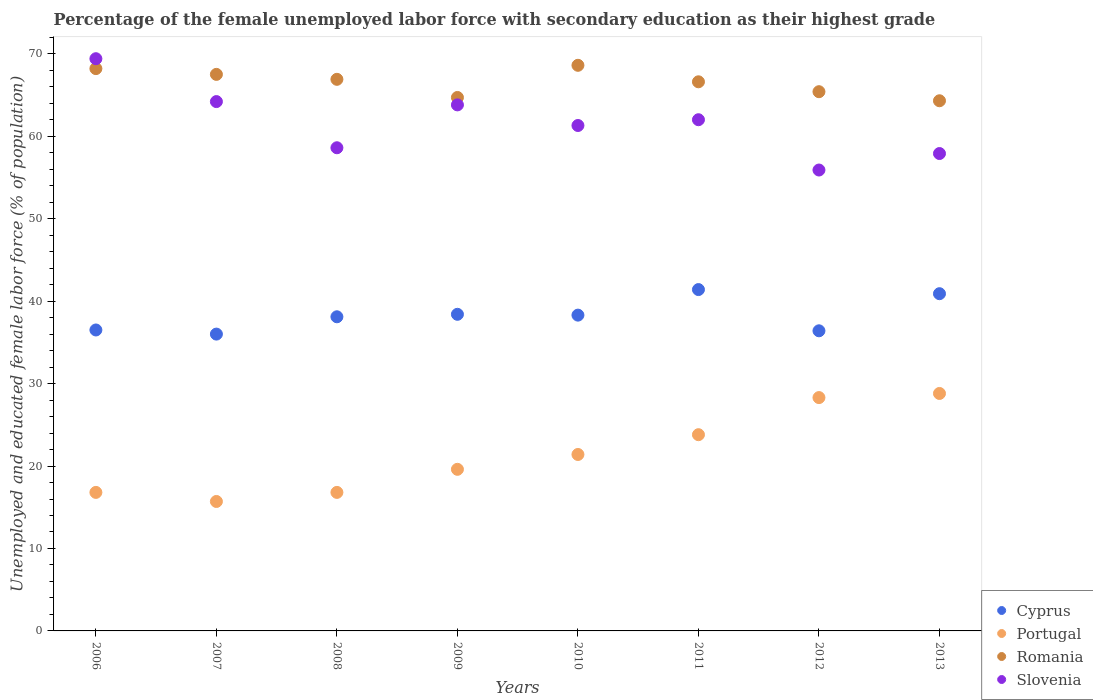How many different coloured dotlines are there?
Keep it short and to the point. 4. What is the percentage of the unemployed female labor force with secondary education in Cyprus in 2006?
Ensure brevity in your answer.  36.5. Across all years, what is the maximum percentage of the unemployed female labor force with secondary education in Portugal?
Make the answer very short. 28.8. In which year was the percentage of the unemployed female labor force with secondary education in Romania minimum?
Offer a very short reply. 2013. What is the total percentage of the unemployed female labor force with secondary education in Romania in the graph?
Provide a short and direct response. 532.2. What is the difference between the percentage of the unemployed female labor force with secondary education in Romania in 2009 and that in 2013?
Give a very brief answer. 0.4. What is the difference between the percentage of the unemployed female labor force with secondary education in Cyprus in 2006 and the percentage of the unemployed female labor force with secondary education in Slovenia in 2009?
Ensure brevity in your answer.  -27.3. What is the average percentage of the unemployed female labor force with secondary education in Romania per year?
Provide a succinct answer. 66.52. In the year 2008, what is the difference between the percentage of the unemployed female labor force with secondary education in Slovenia and percentage of the unemployed female labor force with secondary education in Romania?
Offer a very short reply. -8.3. What is the ratio of the percentage of the unemployed female labor force with secondary education in Romania in 2009 to that in 2010?
Your answer should be compact. 0.94. What is the difference between the highest and the second highest percentage of the unemployed female labor force with secondary education in Slovenia?
Keep it short and to the point. 5.2. What is the difference between the highest and the lowest percentage of the unemployed female labor force with secondary education in Slovenia?
Your answer should be compact. 13.5. In how many years, is the percentage of the unemployed female labor force with secondary education in Romania greater than the average percentage of the unemployed female labor force with secondary education in Romania taken over all years?
Provide a short and direct response. 5. Is it the case that in every year, the sum of the percentage of the unemployed female labor force with secondary education in Portugal and percentage of the unemployed female labor force with secondary education in Cyprus  is greater than the sum of percentage of the unemployed female labor force with secondary education in Slovenia and percentage of the unemployed female labor force with secondary education in Romania?
Give a very brief answer. No. Does the percentage of the unemployed female labor force with secondary education in Slovenia monotonically increase over the years?
Provide a succinct answer. No. Is the percentage of the unemployed female labor force with secondary education in Cyprus strictly greater than the percentage of the unemployed female labor force with secondary education in Portugal over the years?
Provide a succinct answer. Yes. How many dotlines are there?
Make the answer very short. 4. What is the difference between two consecutive major ticks on the Y-axis?
Provide a succinct answer. 10. Does the graph contain any zero values?
Offer a terse response. No. Where does the legend appear in the graph?
Ensure brevity in your answer.  Bottom right. How many legend labels are there?
Your answer should be compact. 4. What is the title of the graph?
Your response must be concise. Percentage of the female unemployed labor force with secondary education as their highest grade. What is the label or title of the Y-axis?
Offer a very short reply. Unemployed and educated female labor force (% of population). What is the Unemployed and educated female labor force (% of population) of Cyprus in 2006?
Provide a short and direct response. 36.5. What is the Unemployed and educated female labor force (% of population) of Portugal in 2006?
Provide a short and direct response. 16.8. What is the Unemployed and educated female labor force (% of population) of Romania in 2006?
Make the answer very short. 68.2. What is the Unemployed and educated female labor force (% of population) of Slovenia in 2006?
Your response must be concise. 69.4. What is the Unemployed and educated female labor force (% of population) in Cyprus in 2007?
Your answer should be compact. 36. What is the Unemployed and educated female labor force (% of population) of Portugal in 2007?
Provide a succinct answer. 15.7. What is the Unemployed and educated female labor force (% of population) in Romania in 2007?
Provide a succinct answer. 67.5. What is the Unemployed and educated female labor force (% of population) in Slovenia in 2007?
Provide a succinct answer. 64.2. What is the Unemployed and educated female labor force (% of population) in Cyprus in 2008?
Your answer should be compact. 38.1. What is the Unemployed and educated female labor force (% of population) of Portugal in 2008?
Provide a succinct answer. 16.8. What is the Unemployed and educated female labor force (% of population) of Romania in 2008?
Your response must be concise. 66.9. What is the Unemployed and educated female labor force (% of population) of Slovenia in 2008?
Provide a short and direct response. 58.6. What is the Unemployed and educated female labor force (% of population) in Cyprus in 2009?
Provide a succinct answer. 38.4. What is the Unemployed and educated female labor force (% of population) of Portugal in 2009?
Give a very brief answer. 19.6. What is the Unemployed and educated female labor force (% of population) of Romania in 2009?
Provide a succinct answer. 64.7. What is the Unemployed and educated female labor force (% of population) in Slovenia in 2009?
Provide a succinct answer. 63.8. What is the Unemployed and educated female labor force (% of population) of Cyprus in 2010?
Provide a succinct answer. 38.3. What is the Unemployed and educated female labor force (% of population) of Portugal in 2010?
Offer a terse response. 21.4. What is the Unemployed and educated female labor force (% of population) of Romania in 2010?
Give a very brief answer. 68.6. What is the Unemployed and educated female labor force (% of population) in Slovenia in 2010?
Offer a terse response. 61.3. What is the Unemployed and educated female labor force (% of population) in Cyprus in 2011?
Give a very brief answer. 41.4. What is the Unemployed and educated female labor force (% of population) of Portugal in 2011?
Keep it short and to the point. 23.8. What is the Unemployed and educated female labor force (% of population) of Romania in 2011?
Your answer should be compact. 66.6. What is the Unemployed and educated female labor force (% of population) of Cyprus in 2012?
Provide a succinct answer. 36.4. What is the Unemployed and educated female labor force (% of population) of Portugal in 2012?
Your response must be concise. 28.3. What is the Unemployed and educated female labor force (% of population) in Romania in 2012?
Give a very brief answer. 65.4. What is the Unemployed and educated female labor force (% of population) of Slovenia in 2012?
Offer a terse response. 55.9. What is the Unemployed and educated female labor force (% of population) of Cyprus in 2013?
Your answer should be very brief. 40.9. What is the Unemployed and educated female labor force (% of population) of Portugal in 2013?
Offer a very short reply. 28.8. What is the Unemployed and educated female labor force (% of population) in Romania in 2013?
Your answer should be compact. 64.3. What is the Unemployed and educated female labor force (% of population) of Slovenia in 2013?
Offer a very short reply. 57.9. Across all years, what is the maximum Unemployed and educated female labor force (% of population) in Cyprus?
Provide a short and direct response. 41.4. Across all years, what is the maximum Unemployed and educated female labor force (% of population) in Portugal?
Your answer should be compact. 28.8. Across all years, what is the maximum Unemployed and educated female labor force (% of population) of Romania?
Keep it short and to the point. 68.6. Across all years, what is the maximum Unemployed and educated female labor force (% of population) of Slovenia?
Give a very brief answer. 69.4. Across all years, what is the minimum Unemployed and educated female labor force (% of population) in Cyprus?
Offer a terse response. 36. Across all years, what is the minimum Unemployed and educated female labor force (% of population) of Portugal?
Ensure brevity in your answer.  15.7. Across all years, what is the minimum Unemployed and educated female labor force (% of population) of Romania?
Provide a succinct answer. 64.3. Across all years, what is the minimum Unemployed and educated female labor force (% of population) of Slovenia?
Your response must be concise. 55.9. What is the total Unemployed and educated female labor force (% of population) in Cyprus in the graph?
Offer a terse response. 306. What is the total Unemployed and educated female labor force (% of population) of Portugal in the graph?
Your answer should be compact. 171.2. What is the total Unemployed and educated female labor force (% of population) in Romania in the graph?
Offer a terse response. 532.2. What is the total Unemployed and educated female labor force (% of population) of Slovenia in the graph?
Your answer should be very brief. 493.1. What is the difference between the Unemployed and educated female labor force (% of population) of Cyprus in 2006 and that in 2007?
Make the answer very short. 0.5. What is the difference between the Unemployed and educated female labor force (% of population) in Portugal in 2006 and that in 2007?
Offer a terse response. 1.1. What is the difference between the Unemployed and educated female labor force (% of population) in Romania in 2006 and that in 2007?
Keep it short and to the point. 0.7. What is the difference between the Unemployed and educated female labor force (% of population) of Portugal in 2006 and that in 2008?
Provide a succinct answer. 0. What is the difference between the Unemployed and educated female labor force (% of population) in Romania in 2006 and that in 2008?
Ensure brevity in your answer.  1.3. What is the difference between the Unemployed and educated female labor force (% of population) in Slovenia in 2006 and that in 2008?
Keep it short and to the point. 10.8. What is the difference between the Unemployed and educated female labor force (% of population) in Cyprus in 2006 and that in 2009?
Make the answer very short. -1.9. What is the difference between the Unemployed and educated female labor force (% of population) in Romania in 2006 and that in 2009?
Offer a very short reply. 3.5. What is the difference between the Unemployed and educated female labor force (% of population) in Slovenia in 2006 and that in 2009?
Your response must be concise. 5.6. What is the difference between the Unemployed and educated female labor force (% of population) in Cyprus in 2006 and that in 2011?
Offer a very short reply. -4.9. What is the difference between the Unemployed and educated female labor force (% of population) of Romania in 2006 and that in 2011?
Provide a short and direct response. 1.6. What is the difference between the Unemployed and educated female labor force (% of population) in Cyprus in 2006 and that in 2012?
Provide a short and direct response. 0.1. What is the difference between the Unemployed and educated female labor force (% of population) of Portugal in 2006 and that in 2012?
Offer a very short reply. -11.5. What is the difference between the Unemployed and educated female labor force (% of population) of Romania in 2006 and that in 2012?
Keep it short and to the point. 2.8. What is the difference between the Unemployed and educated female labor force (% of population) of Slovenia in 2006 and that in 2012?
Make the answer very short. 13.5. What is the difference between the Unemployed and educated female labor force (% of population) in Cyprus in 2006 and that in 2013?
Make the answer very short. -4.4. What is the difference between the Unemployed and educated female labor force (% of population) of Portugal in 2006 and that in 2013?
Keep it short and to the point. -12. What is the difference between the Unemployed and educated female labor force (% of population) in Romania in 2006 and that in 2013?
Give a very brief answer. 3.9. What is the difference between the Unemployed and educated female labor force (% of population) of Romania in 2007 and that in 2008?
Your answer should be very brief. 0.6. What is the difference between the Unemployed and educated female labor force (% of population) in Cyprus in 2007 and that in 2010?
Provide a succinct answer. -2.3. What is the difference between the Unemployed and educated female labor force (% of population) of Portugal in 2007 and that in 2010?
Keep it short and to the point. -5.7. What is the difference between the Unemployed and educated female labor force (% of population) of Slovenia in 2007 and that in 2011?
Offer a terse response. 2.2. What is the difference between the Unemployed and educated female labor force (% of population) in Portugal in 2007 and that in 2012?
Ensure brevity in your answer.  -12.6. What is the difference between the Unemployed and educated female labor force (% of population) of Cyprus in 2007 and that in 2013?
Your answer should be compact. -4.9. What is the difference between the Unemployed and educated female labor force (% of population) of Portugal in 2007 and that in 2013?
Ensure brevity in your answer.  -13.1. What is the difference between the Unemployed and educated female labor force (% of population) in Slovenia in 2007 and that in 2013?
Offer a terse response. 6.3. What is the difference between the Unemployed and educated female labor force (% of population) in Cyprus in 2008 and that in 2009?
Provide a succinct answer. -0.3. What is the difference between the Unemployed and educated female labor force (% of population) of Romania in 2008 and that in 2009?
Make the answer very short. 2.2. What is the difference between the Unemployed and educated female labor force (% of population) in Slovenia in 2008 and that in 2009?
Keep it short and to the point. -5.2. What is the difference between the Unemployed and educated female labor force (% of population) of Cyprus in 2008 and that in 2010?
Make the answer very short. -0.2. What is the difference between the Unemployed and educated female labor force (% of population) in Portugal in 2008 and that in 2010?
Offer a very short reply. -4.6. What is the difference between the Unemployed and educated female labor force (% of population) in Romania in 2008 and that in 2010?
Keep it short and to the point. -1.7. What is the difference between the Unemployed and educated female labor force (% of population) of Slovenia in 2008 and that in 2010?
Keep it short and to the point. -2.7. What is the difference between the Unemployed and educated female labor force (% of population) of Portugal in 2008 and that in 2011?
Your answer should be very brief. -7. What is the difference between the Unemployed and educated female labor force (% of population) of Slovenia in 2008 and that in 2011?
Provide a succinct answer. -3.4. What is the difference between the Unemployed and educated female labor force (% of population) of Portugal in 2008 and that in 2012?
Your answer should be very brief. -11.5. What is the difference between the Unemployed and educated female labor force (% of population) in Slovenia in 2008 and that in 2012?
Offer a very short reply. 2.7. What is the difference between the Unemployed and educated female labor force (% of population) of Cyprus in 2008 and that in 2013?
Ensure brevity in your answer.  -2.8. What is the difference between the Unemployed and educated female labor force (% of population) in Romania in 2008 and that in 2013?
Keep it short and to the point. 2.6. What is the difference between the Unemployed and educated female labor force (% of population) of Cyprus in 2009 and that in 2010?
Provide a succinct answer. 0.1. What is the difference between the Unemployed and educated female labor force (% of population) in Portugal in 2009 and that in 2010?
Give a very brief answer. -1.8. What is the difference between the Unemployed and educated female labor force (% of population) in Romania in 2009 and that in 2010?
Offer a terse response. -3.9. What is the difference between the Unemployed and educated female labor force (% of population) in Portugal in 2009 and that in 2011?
Give a very brief answer. -4.2. What is the difference between the Unemployed and educated female labor force (% of population) of Romania in 2009 and that in 2011?
Your response must be concise. -1.9. What is the difference between the Unemployed and educated female labor force (% of population) in Slovenia in 2009 and that in 2011?
Ensure brevity in your answer.  1.8. What is the difference between the Unemployed and educated female labor force (% of population) of Portugal in 2009 and that in 2012?
Offer a very short reply. -8.7. What is the difference between the Unemployed and educated female labor force (% of population) in Slovenia in 2009 and that in 2012?
Provide a short and direct response. 7.9. What is the difference between the Unemployed and educated female labor force (% of population) of Cyprus in 2010 and that in 2011?
Ensure brevity in your answer.  -3.1. What is the difference between the Unemployed and educated female labor force (% of population) of Cyprus in 2010 and that in 2012?
Your answer should be very brief. 1.9. What is the difference between the Unemployed and educated female labor force (% of population) of Portugal in 2010 and that in 2012?
Make the answer very short. -6.9. What is the difference between the Unemployed and educated female labor force (% of population) in Romania in 2010 and that in 2012?
Ensure brevity in your answer.  3.2. What is the difference between the Unemployed and educated female labor force (% of population) of Portugal in 2010 and that in 2013?
Ensure brevity in your answer.  -7.4. What is the difference between the Unemployed and educated female labor force (% of population) in Romania in 2010 and that in 2013?
Your answer should be very brief. 4.3. What is the difference between the Unemployed and educated female labor force (% of population) of Portugal in 2011 and that in 2012?
Your response must be concise. -4.5. What is the difference between the Unemployed and educated female labor force (% of population) of Cyprus in 2011 and that in 2013?
Keep it short and to the point. 0.5. What is the difference between the Unemployed and educated female labor force (% of population) of Romania in 2011 and that in 2013?
Your answer should be very brief. 2.3. What is the difference between the Unemployed and educated female labor force (% of population) in Slovenia in 2011 and that in 2013?
Provide a short and direct response. 4.1. What is the difference between the Unemployed and educated female labor force (% of population) of Cyprus in 2012 and that in 2013?
Offer a very short reply. -4.5. What is the difference between the Unemployed and educated female labor force (% of population) in Romania in 2012 and that in 2013?
Your response must be concise. 1.1. What is the difference between the Unemployed and educated female labor force (% of population) of Cyprus in 2006 and the Unemployed and educated female labor force (% of population) of Portugal in 2007?
Provide a short and direct response. 20.8. What is the difference between the Unemployed and educated female labor force (% of population) in Cyprus in 2006 and the Unemployed and educated female labor force (% of population) in Romania in 2007?
Offer a very short reply. -31. What is the difference between the Unemployed and educated female labor force (% of population) of Cyprus in 2006 and the Unemployed and educated female labor force (% of population) of Slovenia in 2007?
Offer a terse response. -27.7. What is the difference between the Unemployed and educated female labor force (% of population) of Portugal in 2006 and the Unemployed and educated female labor force (% of population) of Romania in 2007?
Your answer should be very brief. -50.7. What is the difference between the Unemployed and educated female labor force (% of population) in Portugal in 2006 and the Unemployed and educated female labor force (% of population) in Slovenia in 2007?
Make the answer very short. -47.4. What is the difference between the Unemployed and educated female labor force (% of population) in Romania in 2006 and the Unemployed and educated female labor force (% of population) in Slovenia in 2007?
Make the answer very short. 4. What is the difference between the Unemployed and educated female labor force (% of population) in Cyprus in 2006 and the Unemployed and educated female labor force (% of population) in Portugal in 2008?
Give a very brief answer. 19.7. What is the difference between the Unemployed and educated female labor force (% of population) of Cyprus in 2006 and the Unemployed and educated female labor force (% of population) of Romania in 2008?
Give a very brief answer. -30.4. What is the difference between the Unemployed and educated female labor force (% of population) in Cyprus in 2006 and the Unemployed and educated female labor force (% of population) in Slovenia in 2008?
Provide a short and direct response. -22.1. What is the difference between the Unemployed and educated female labor force (% of population) of Portugal in 2006 and the Unemployed and educated female labor force (% of population) of Romania in 2008?
Give a very brief answer. -50.1. What is the difference between the Unemployed and educated female labor force (% of population) in Portugal in 2006 and the Unemployed and educated female labor force (% of population) in Slovenia in 2008?
Offer a very short reply. -41.8. What is the difference between the Unemployed and educated female labor force (% of population) in Romania in 2006 and the Unemployed and educated female labor force (% of population) in Slovenia in 2008?
Keep it short and to the point. 9.6. What is the difference between the Unemployed and educated female labor force (% of population) in Cyprus in 2006 and the Unemployed and educated female labor force (% of population) in Portugal in 2009?
Provide a short and direct response. 16.9. What is the difference between the Unemployed and educated female labor force (% of population) of Cyprus in 2006 and the Unemployed and educated female labor force (% of population) of Romania in 2009?
Give a very brief answer. -28.2. What is the difference between the Unemployed and educated female labor force (% of population) of Cyprus in 2006 and the Unemployed and educated female labor force (% of population) of Slovenia in 2009?
Ensure brevity in your answer.  -27.3. What is the difference between the Unemployed and educated female labor force (% of population) of Portugal in 2006 and the Unemployed and educated female labor force (% of population) of Romania in 2009?
Give a very brief answer. -47.9. What is the difference between the Unemployed and educated female labor force (% of population) in Portugal in 2006 and the Unemployed and educated female labor force (% of population) in Slovenia in 2009?
Provide a short and direct response. -47. What is the difference between the Unemployed and educated female labor force (% of population) of Cyprus in 2006 and the Unemployed and educated female labor force (% of population) of Romania in 2010?
Provide a short and direct response. -32.1. What is the difference between the Unemployed and educated female labor force (% of population) in Cyprus in 2006 and the Unemployed and educated female labor force (% of population) in Slovenia in 2010?
Your response must be concise. -24.8. What is the difference between the Unemployed and educated female labor force (% of population) of Portugal in 2006 and the Unemployed and educated female labor force (% of population) of Romania in 2010?
Give a very brief answer. -51.8. What is the difference between the Unemployed and educated female labor force (% of population) of Portugal in 2006 and the Unemployed and educated female labor force (% of population) of Slovenia in 2010?
Give a very brief answer. -44.5. What is the difference between the Unemployed and educated female labor force (% of population) of Cyprus in 2006 and the Unemployed and educated female labor force (% of population) of Portugal in 2011?
Offer a terse response. 12.7. What is the difference between the Unemployed and educated female labor force (% of population) in Cyprus in 2006 and the Unemployed and educated female labor force (% of population) in Romania in 2011?
Keep it short and to the point. -30.1. What is the difference between the Unemployed and educated female labor force (% of population) of Cyprus in 2006 and the Unemployed and educated female labor force (% of population) of Slovenia in 2011?
Your answer should be very brief. -25.5. What is the difference between the Unemployed and educated female labor force (% of population) of Portugal in 2006 and the Unemployed and educated female labor force (% of population) of Romania in 2011?
Ensure brevity in your answer.  -49.8. What is the difference between the Unemployed and educated female labor force (% of population) of Portugal in 2006 and the Unemployed and educated female labor force (% of population) of Slovenia in 2011?
Offer a very short reply. -45.2. What is the difference between the Unemployed and educated female labor force (% of population) in Romania in 2006 and the Unemployed and educated female labor force (% of population) in Slovenia in 2011?
Offer a terse response. 6.2. What is the difference between the Unemployed and educated female labor force (% of population) in Cyprus in 2006 and the Unemployed and educated female labor force (% of population) in Romania in 2012?
Keep it short and to the point. -28.9. What is the difference between the Unemployed and educated female labor force (% of population) in Cyprus in 2006 and the Unemployed and educated female labor force (% of population) in Slovenia in 2012?
Make the answer very short. -19.4. What is the difference between the Unemployed and educated female labor force (% of population) in Portugal in 2006 and the Unemployed and educated female labor force (% of population) in Romania in 2012?
Your response must be concise. -48.6. What is the difference between the Unemployed and educated female labor force (% of population) in Portugal in 2006 and the Unemployed and educated female labor force (% of population) in Slovenia in 2012?
Ensure brevity in your answer.  -39.1. What is the difference between the Unemployed and educated female labor force (% of population) in Romania in 2006 and the Unemployed and educated female labor force (% of population) in Slovenia in 2012?
Give a very brief answer. 12.3. What is the difference between the Unemployed and educated female labor force (% of population) in Cyprus in 2006 and the Unemployed and educated female labor force (% of population) in Portugal in 2013?
Provide a short and direct response. 7.7. What is the difference between the Unemployed and educated female labor force (% of population) of Cyprus in 2006 and the Unemployed and educated female labor force (% of population) of Romania in 2013?
Provide a short and direct response. -27.8. What is the difference between the Unemployed and educated female labor force (% of population) of Cyprus in 2006 and the Unemployed and educated female labor force (% of population) of Slovenia in 2013?
Offer a terse response. -21.4. What is the difference between the Unemployed and educated female labor force (% of population) of Portugal in 2006 and the Unemployed and educated female labor force (% of population) of Romania in 2013?
Your answer should be compact. -47.5. What is the difference between the Unemployed and educated female labor force (% of population) of Portugal in 2006 and the Unemployed and educated female labor force (% of population) of Slovenia in 2013?
Your answer should be compact. -41.1. What is the difference between the Unemployed and educated female labor force (% of population) in Romania in 2006 and the Unemployed and educated female labor force (% of population) in Slovenia in 2013?
Offer a very short reply. 10.3. What is the difference between the Unemployed and educated female labor force (% of population) of Cyprus in 2007 and the Unemployed and educated female labor force (% of population) of Romania in 2008?
Ensure brevity in your answer.  -30.9. What is the difference between the Unemployed and educated female labor force (% of population) of Cyprus in 2007 and the Unemployed and educated female labor force (% of population) of Slovenia in 2008?
Your answer should be compact. -22.6. What is the difference between the Unemployed and educated female labor force (% of population) of Portugal in 2007 and the Unemployed and educated female labor force (% of population) of Romania in 2008?
Offer a terse response. -51.2. What is the difference between the Unemployed and educated female labor force (% of population) in Portugal in 2007 and the Unemployed and educated female labor force (% of population) in Slovenia in 2008?
Offer a very short reply. -42.9. What is the difference between the Unemployed and educated female labor force (% of population) in Romania in 2007 and the Unemployed and educated female labor force (% of population) in Slovenia in 2008?
Offer a very short reply. 8.9. What is the difference between the Unemployed and educated female labor force (% of population) in Cyprus in 2007 and the Unemployed and educated female labor force (% of population) in Portugal in 2009?
Keep it short and to the point. 16.4. What is the difference between the Unemployed and educated female labor force (% of population) of Cyprus in 2007 and the Unemployed and educated female labor force (% of population) of Romania in 2009?
Offer a very short reply. -28.7. What is the difference between the Unemployed and educated female labor force (% of population) of Cyprus in 2007 and the Unemployed and educated female labor force (% of population) of Slovenia in 2009?
Ensure brevity in your answer.  -27.8. What is the difference between the Unemployed and educated female labor force (% of population) of Portugal in 2007 and the Unemployed and educated female labor force (% of population) of Romania in 2009?
Your answer should be compact. -49. What is the difference between the Unemployed and educated female labor force (% of population) in Portugal in 2007 and the Unemployed and educated female labor force (% of population) in Slovenia in 2009?
Ensure brevity in your answer.  -48.1. What is the difference between the Unemployed and educated female labor force (% of population) in Romania in 2007 and the Unemployed and educated female labor force (% of population) in Slovenia in 2009?
Provide a succinct answer. 3.7. What is the difference between the Unemployed and educated female labor force (% of population) in Cyprus in 2007 and the Unemployed and educated female labor force (% of population) in Portugal in 2010?
Your answer should be compact. 14.6. What is the difference between the Unemployed and educated female labor force (% of population) of Cyprus in 2007 and the Unemployed and educated female labor force (% of population) of Romania in 2010?
Make the answer very short. -32.6. What is the difference between the Unemployed and educated female labor force (% of population) in Cyprus in 2007 and the Unemployed and educated female labor force (% of population) in Slovenia in 2010?
Provide a short and direct response. -25.3. What is the difference between the Unemployed and educated female labor force (% of population) of Portugal in 2007 and the Unemployed and educated female labor force (% of population) of Romania in 2010?
Give a very brief answer. -52.9. What is the difference between the Unemployed and educated female labor force (% of population) of Portugal in 2007 and the Unemployed and educated female labor force (% of population) of Slovenia in 2010?
Provide a short and direct response. -45.6. What is the difference between the Unemployed and educated female labor force (% of population) of Cyprus in 2007 and the Unemployed and educated female labor force (% of population) of Romania in 2011?
Provide a succinct answer. -30.6. What is the difference between the Unemployed and educated female labor force (% of population) of Portugal in 2007 and the Unemployed and educated female labor force (% of population) of Romania in 2011?
Provide a succinct answer. -50.9. What is the difference between the Unemployed and educated female labor force (% of population) of Portugal in 2007 and the Unemployed and educated female labor force (% of population) of Slovenia in 2011?
Offer a very short reply. -46.3. What is the difference between the Unemployed and educated female labor force (% of population) in Cyprus in 2007 and the Unemployed and educated female labor force (% of population) in Romania in 2012?
Offer a terse response. -29.4. What is the difference between the Unemployed and educated female labor force (% of population) in Cyprus in 2007 and the Unemployed and educated female labor force (% of population) in Slovenia in 2012?
Your answer should be very brief. -19.9. What is the difference between the Unemployed and educated female labor force (% of population) of Portugal in 2007 and the Unemployed and educated female labor force (% of population) of Romania in 2012?
Your answer should be compact. -49.7. What is the difference between the Unemployed and educated female labor force (% of population) in Portugal in 2007 and the Unemployed and educated female labor force (% of population) in Slovenia in 2012?
Give a very brief answer. -40.2. What is the difference between the Unemployed and educated female labor force (% of population) of Romania in 2007 and the Unemployed and educated female labor force (% of population) of Slovenia in 2012?
Your response must be concise. 11.6. What is the difference between the Unemployed and educated female labor force (% of population) of Cyprus in 2007 and the Unemployed and educated female labor force (% of population) of Romania in 2013?
Give a very brief answer. -28.3. What is the difference between the Unemployed and educated female labor force (% of population) of Cyprus in 2007 and the Unemployed and educated female labor force (% of population) of Slovenia in 2013?
Make the answer very short. -21.9. What is the difference between the Unemployed and educated female labor force (% of population) in Portugal in 2007 and the Unemployed and educated female labor force (% of population) in Romania in 2013?
Make the answer very short. -48.6. What is the difference between the Unemployed and educated female labor force (% of population) of Portugal in 2007 and the Unemployed and educated female labor force (% of population) of Slovenia in 2013?
Offer a terse response. -42.2. What is the difference between the Unemployed and educated female labor force (% of population) of Romania in 2007 and the Unemployed and educated female labor force (% of population) of Slovenia in 2013?
Provide a succinct answer. 9.6. What is the difference between the Unemployed and educated female labor force (% of population) of Cyprus in 2008 and the Unemployed and educated female labor force (% of population) of Portugal in 2009?
Your answer should be compact. 18.5. What is the difference between the Unemployed and educated female labor force (% of population) of Cyprus in 2008 and the Unemployed and educated female labor force (% of population) of Romania in 2009?
Make the answer very short. -26.6. What is the difference between the Unemployed and educated female labor force (% of population) of Cyprus in 2008 and the Unemployed and educated female labor force (% of population) of Slovenia in 2009?
Your answer should be very brief. -25.7. What is the difference between the Unemployed and educated female labor force (% of population) in Portugal in 2008 and the Unemployed and educated female labor force (% of population) in Romania in 2009?
Provide a short and direct response. -47.9. What is the difference between the Unemployed and educated female labor force (% of population) of Portugal in 2008 and the Unemployed and educated female labor force (% of population) of Slovenia in 2009?
Provide a succinct answer. -47. What is the difference between the Unemployed and educated female labor force (% of population) in Cyprus in 2008 and the Unemployed and educated female labor force (% of population) in Romania in 2010?
Offer a terse response. -30.5. What is the difference between the Unemployed and educated female labor force (% of population) in Cyprus in 2008 and the Unemployed and educated female labor force (% of population) in Slovenia in 2010?
Give a very brief answer. -23.2. What is the difference between the Unemployed and educated female labor force (% of population) in Portugal in 2008 and the Unemployed and educated female labor force (% of population) in Romania in 2010?
Provide a short and direct response. -51.8. What is the difference between the Unemployed and educated female labor force (% of population) of Portugal in 2008 and the Unemployed and educated female labor force (% of population) of Slovenia in 2010?
Offer a terse response. -44.5. What is the difference between the Unemployed and educated female labor force (% of population) in Romania in 2008 and the Unemployed and educated female labor force (% of population) in Slovenia in 2010?
Your answer should be very brief. 5.6. What is the difference between the Unemployed and educated female labor force (% of population) in Cyprus in 2008 and the Unemployed and educated female labor force (% of population) in Romania in 2011?
Provide a short and direct response. -28.5. What is the difference between the Unemployed and educated female labor force (% of population) in Cyprus in 2008 and the Unemployed and educated female labor force (% of population) in Slovenia in 2011?
Offer a terse response. -23.9. What is the difference between the Unemployed and educated female labor force (% of population) of Portugal in 2008 and the Unemployed and educated female labor force (% of population) of Romania in 2011?
Your answer should be compact. -49.8. What is the difference between the Unemployed and educated female labor force (% of population) in Portugal in 2008 and the Unemployed and educated female labor force (% of population) in Slovenia in 2011?
Provide a short and direct response. -45.2. What is the difference between the Unemployed and educated female labor force (% of population) in Romania in 2008 and the Unemployed and educated female labor force (% of population) in Slovenia in 2011?
Ensure brevity in your answer.  4.9. What is the difference between the Unemployed and educated female labor force (% of population) in Cyprus in 2008 and the Unemployed and educated female labor force (% of population) in Portugal in 2012?
Your answer should be very brief. 9.8. What is the difference between the Unemployed and educated female labor force (% of population) in Cyprus in 2008 and the Unemployed and educated female labor force (% of population) in Romania in 2012?
Keep it short and to the point. -27.3. What is the difference between the Unemployed and educated female labor force (% of population) in Cyprus in 2008 and the Unemployed and educated female labor force (% of population) in Slovenia in 2012?
Provide a succinct answer. -17.8. What is the difference between the Unemployed and educated female labor force (% of population) in Portugal in 2008 and the Unemployed and educated female labor force (% of population) in Romania in 2012?
Keep it short and to the point. -48.6. What is the difference between the Unemployed and educated female labor force (% of population) in Portugal in 2008 and the Unemployed and educated female labor force (% of population) in Slovenia in 2012?
Provide a succinct answer. -39.1. What is the difference between the Unemployed and educated female labor force (% of population) of Cyprus in 2008 and the Unemployed and educated female labor force (% of population) of Romania in 2013?
Your answer should be very brief. -26.2. What is the difference between the Unemployed and educated female labor force (% of population) of Cyprus in 2008 and the Unemployed and educated female labor force (% of population) of Slovenia in 2013?
Provide a succinct answer. -19.8. What is the difference between the Unemployed and educated female labor force (% of population) of Portugal in 2008 and the Unemployed and educated female labor force (% of population) of Romania in 2013?
Make the answer very short. -47.5. What is the difference between the Unemployed and educated female labor force (% of population) of Portugal in 2008 and the Unemployed and educated female labor force (% of population) of Slovenia in 2013?
Your response must be concise. -41.1. What is the difference between the Unemployed and educated female labor force (% of population) of Romania in 2008 and the Unemployed and educated female labor force (% of population) of Slovenia in 2013?
Ensure brevity in your answer.  9. What is the difference between the Unemployed and educated female labor force (% of population) of Cyprus in 2009 and the Unemployed and educated female labor force (% of population) of Portugal in 2010?
Your answer should be very brief. 17. What is the difference between the Unemployed and educated female labor force (% of population) in Cyprus in 2009 and the Unemployed and educated female labor force (% of population) in Romania in 2010?
Ensure brevity in your answer.  -30.2. What is the difference between the Unemployed and educated female labor force (% of population) of Cyprus in 2009 and the Unemployed and educated female labor force (% of population) of Slovenia in 2010?
Make the answer very short. -22.9. What is the difference between the Unemployed and educated female labor force (% of population) in Portugal in 2009 and the Unemployed and educated female labor force (% of population) in Romania in 2010?
Your answer should be very brief. -49. What is the difference between the Unemployed and educated female labor force (% of population) in Portugal in 2009 and the Unemployed and educated female labor force (% of population) in Slovenia in 2010?
Make the answer very short. -41.7. What is the difference between the Unemployed and educated female labor force (% of population) in Cyprus in 2009 and the Unemployed and educated female labor force (% of population) in Romania in 2011?
Make the answer very short. -28.2. What is the difference between the Unemployed and educated female labor force (% of population) of Cyprus in 2009 and the Unemployed and educated female labor force (% of population) of Slovenia in 2011?
Offer a very short reply. -23.6. What is the difference between the Unemployed and educated female labor force (% of population) in Portugal in 2009 and the Unemployed and educated female labor force (% of population) in Romania in 2011?
Make the answer very short. -47. What is the difference between the Unemployed and educated female labor force (% of population) of Portugal in 2009 and the Unemployed and educated female labor force (% of population) of Slovenia in 2011?
Your response must be concise. -42.4. What is the difference between the Unemployed and educated female labor force (% of population) of Cyprus in 2009 and the Unemployed and educated female labor force (% of population) of Romania in 2012?
Your response must be concise. -27. What is the difference between the Unemployed and educated female labor force (% of population) in Cyprus in 2009 and the Unemployed and educated female labor force (% of population) in Slovenia in 2012?
Provide a short and direct response. -17.5. What is the difference between the Unemployed and educated female labor force (% of population) in Portugal in 2009 and the Unemployed and educated female labor force (% of population) in Romania in 2012?
Offer a very short reply. -45.8. What is the difference between the Unemployed and educated female labor force (% of population) of Portugal in 2009 and the Unemployed and educated female labor force (% of population) of Slovenia in 2012?
Make the answer very short. -36.3. What is the difference between the Unemployed and educated female labor force (% of population) in Romania in 2009 and the Unemployed and educated female labor force (% of population) in Slovenia in 2012?
Give a very brief answer. 8.8. What is the difference between the Unemployed and educated female labor force (% of population) of Cyprus in 2009 and the Unemployed and educated female labor force (% of population) of Romania in 2013?
Give a very brief answer. -25.9. What is the difference between the Unemployed and educated female labor force (% of population) in Cyprus in 2009 and the Unemployed and educated female labor force (% of population) in Slovenia in 2013?
Provide a succinct answer. -19.5. What is the difference between the Unemployed and educated female labor force (% of population) in Portugal in 2009 and the Unemployed and educated female labor force (% of population) in Romania in 2013?
Offer a terse response. -44.7. What is the difference between the Unemployed and educated female labor force (% of population) in Portugal in 2009 and the Unemployed and educated female labor force (% of population) in Slovenia in 2013?
Your answer should be compact. -38.3. What is the difference between the Unemployed and educated female labor force (% of population) in Romania in 2009 and the Unemployed and educated female labor force (% of population) in Slovenia in 2013?
Offer a terse response. 6.8. What is the difference between the Unemployed and educated female labor force (% of population) in Cyprus in 2010 and the Unemployed and educated female labor force (% of population) in Romania in 2011?
Give a very brief answer. -28.3. What is the difference between the Unemployed and educated female labor force (% of population) of Cyprus in 2010 and the Unemployed and educated female labor force (% of population) of Slovenia in 2011?
Your response must be concise. -23.7. What is the difference between the Unemployed and educated female labor force (% of population) of Portugal in 2010 and the Unemployed and educated female labor force (% of population) of Romania in 2011?
Your answer should be very brief. -45.2. What is the difference between the Unemployed and educated female labor force (% of population) of Portugal in 2010 and the Unemployed and educated female labor force (% of population) of Slovenia in 2011?
Give a very brief answer. -40.6. What is the difference between the Unemployed and educated female labor force (% of population) of Romania in 2010 and the Unemployed and educated female labor force (% of population) of Slovenia in 2011?
Offer a very short reply. 6.6. What is the difference between the Unemployed and educated female labor force (% of population) in Cyprus in 2010 and the Unemployed and educated female labor force (% of population) in Portugal in 2012?
Provide a succinct answer. 10. What is the difference between the Unemployed and educated female labor force (% of population) in Cyprus in 2010 and the Unemployed and educated female labor force (% of population) in Romania in 2012?
Your answer should be very brief. -27.1. What is the difference between the Unemployed and educated female labor force (% of population) in Cyprus in 2010 and the Unemployed and educated female labor force (% of population) in Slovenia in 2012?
Provide a short and direct response. -17.6. What is the difference between the Unemployed and educated female labor force (% of population) in Portugal in 2010 and the Unemployed and educated female labor force (% of population) in Romania in 2012?
Ensure brevity in your answer.  -44. What is the difference between the Unemployed and educated female labor force (% of population) in Portugal in 2010 and the Unemployed and educated female labor force (% of population) in Slovenia in 2012?
Offer a terse response. -34.5. What is the difference between the Unemployed and educated female labor force (% of population) of Cyprus in 2010 and the Unemployed and educated female labor force (% of population) of Romania in 2013?
Your response must be concise. -26. What is the difference between the Unemployed and educated female labor force (% of population) in Cyprus in 2010 and the Unemployed and educated female labor force (% of population) in Slovenia in 2013?
Make the answer very short. -19.6. What is the difference between the Unemployed and educated female labor force (% of population) in Portugal in 2010 and the Unemployed and educated female labor force (% of population) in Romania in 2013?
Offer a terse response. -42.9. What is the difference between the Unemployed and educated female labor force (% of population) in Portugal in 2010 and the Unemployed and educated female labor force (% of population) in Slovenia in 2013?
Provide a short and direct response. -36.5. What is the difference between the Unemployed and educated female labor force (% of population) of Cyprus in 2011 and the Unemployed and educated female labor force (% of population) of Portugal in 2012?
Your response must be concise. 13.1. What is the difference between the Unemployed and educated female labor force (% of population) in Cyprus in 2011 and the Unemployed and educated female labor force (% of population) in Slovenia in 2012?
Keep it short and to the point. -14.5. What is the difference between the Unemployed and educated female labor force (% of population) in Portugal in 2011 and the Unemployed and educated female labor force (% of population) in Romania in 2012?
Give a very brief answer. -41.6. What is the difference between the Unemployed and educated female labor force (% of population) in Portugal in 2011 and the Unemployed and educated female labor force (% of population) in Slovenia in 2012?
Keep it short and to the point. -32.1. What is the difference between the Unemployed and educated female labor force (% of population) of Romania in 2011 and the Unemployed and educated female labor force (% of population) of Slovenia in 2012?
Offer a terse response. 10.7. What is the difference between the Unemployed and educated female labor force (% of population) of Cyprus in 2011 and the Unemployed and educated female labor force (% of population) of Romania in 2013?
Your answer should be compact. -22.9. What is the difference between the Unemployed and educated female labor force (% of population) of Cyprus in 2011 and the Unemployed and educated female labor force (% of population) of Slovenia in 2013?
Offer a very short reply. -16.5. What is the difference between the Unemployed and educated female labor force (% of population) of Portugal in 2011 and the Unemployed and educated female labor force (% of population) of Romania in 2013?
Offer a very short reply. -40.5. What is the difference between the Unemployed and educated female labor force (% of population) of Portugal in 2011 and the Unemployed and educated female labor force (% of population) of Slovenia in 2013?
Offer a terse response. -34.1. What is the difference between the Unemployed and educated female labor force (% of population) in Romania in 2011 and the Unemployed and educated female labor force (% of population) in Slovenia in 2013?
Offer a very short reply. 8.7. What is the difference between the Unemployed and educated female labor force (% of population) in Cyprus in 2012 and the Unemployed and educated female labor force (% of population) in Romania in 2013?
Your response must be concise. -27.9. What is the difference between the Unemployed and educated female labor force (% of population) of Cyprus in 2012 and the Unemployed and educated female labor force (% of population) of Slovenia in 2013?
Give a very brief answer. -21.5. What is the difference between the Unemployed and educated female labor force (% of population) of Portugal in 2012 and the Unemployed and educated female labor force (% of population) of Romania in 2013?
Your answer should be very brief. -36. What is the difference between the Unemployed and educated female labor force (% of population) in Portugal in 2012 and the Unemployed and educated female labor force (% of population) in Slovenia in 2013?
Keep it short and to the point. -29.6. What is the average Unemployed and educated female labor force (% of population) in Cyprus per year?
Provide a succinct answer. 38.25. What is the average Unemployed and educated female labor force (% of population) in Portugal per year?
Offer a terse response. 21.4. What is the average Unemployed and educated female labor force (% of population) in Romania per year?
Offer a very short reply. 66.53. What is the average Unemployed and educated female labor force (% of population) of Slovenia per year?
Your response must be concise. 61.64. In the year 2006, what is the difference between the Unemployed and educated female labor force (% of population) of Cyprus and Unemployed and educated female labor force (% of population) of Portugal?
Your answer should be very brief. 19.7. In the year 2006, what is the difference between the Unemployed and educated female labor force (% of population) of Cyprus and Unemployed and educated female labor force (% of population) of Romania?
Give a very brief answer. -31.7. In the year 2006, what is the difference between the Unemployed and educated female labor force (% of population) in Cyprus and Unemployed and educated female labor force (% of population) in Slovenia?
Ensure brevity in your answer.  -32.9. In the year 2006, what is the difference between the Unemployed and educated female labor force (% of population) in Portugal and Unemployed and educated female labor force (% of population) in Romania?
Give a very brief answer. -51.4. In the year 2006, what is the difference between the Unemployed and educated female labor force (% of population) of Portugal and Unemployed and educated female labor force (% of population) of Slovenia?
Make the answer very short. -52.6. In the year 2007, what is the difference between the Unemployed and educated female labor force (% of population) of Cyprus and Unemployed and educated female labor force (% of population) of Portugal?
Offer a very short reply. 20.3. In the year 2007, what is the difference between the Unemployed and educated female labor force (% of population) in Cyprus and Unemployed and educated female labor force (% of population) in Romania?
Make the answer very short. -31.5. In the year 2007, what is the difference between the Unemployed and educated female labor force (% of population) of Cyprus and Unemployed and educated female labor force (% of population) of Slovenia?
Make the answer very short. -28.2. In the year 2007, what is the difference between the Unemployed and educated female labor force (% of population) of Portugal and Unemployed and educated female labor force (% of population) of Romania?
Provide a short and direct response. -51.8. In the year 2007, what is the difference between the Unemployed and educated female labor force (% of population) in Portugal and Unemployed and educated female labor force (% of population) in Slovenia?
Your response must be concise. -48.5. In the year 2007, what is the difference between the Unemployed and educated female labor force (% of population) of Romania and Unemployed and educated female labor force (% of population) of Slovenia?
Give a very brief answer. 3.3. In the year 2008, what is the difference between the Unemployed and educated female labor force (% of population) of Cyprus and Unemployed and educated female labor force (% of population) of Portugal?
Give a very brief answer. 21.3. In the year 2008, what is the difference between the Unemployed and educated female labor force (% of population) in Cyprus and Unemployed and educated female labor force (% of population) in Romania?
Your answer should be very brief. -28.8. In the year 2008, what is the difference between the Unemployed and educated female labor force (% of population) of Cyprus and Unemployed and educated female labor force (% of population) of Slovenia?
Offer a very short reply. -20.5. In the year 2008, what is the difference between the Unemployed and educated female labor force (% of population) in Portugal and Unemployed and educated female labor force (% of population) in Romania?
Keep it short and to the point. -50.1. In the year 2008, what is the difference between the Unemployed and educated female labor force (% of population) of Portugal and Unemployed and educated female labor force (% of population) of Slovenia?
Give a very brief answer. -41.8. In the year 2009, what is the difference between the Unemployed and educated female labor force (% of population) of Cyprus and Unemployed and educated female labor force (% of population) of Romania?
Offer a very short reply. -26.3. In the year 2009, what is the difference between the Unemployed and educated female labor force (% of population) in Cyprus and Unemployed and educated female labor force (% of population) in Slovenia?
Give a very brief answer. -25.4. In the year 2009, what is the difference between the Unemployed and educated female labor force (% of population) of Portugal and Unemployed and educated female labor force (% of population) of Romania?
Offer a terse response. -45.1. In the year 2009, what is the difference between the Unemployed and educated female labor force (% of population) in Portugal and Unemployed and educated female labor force (% of population) in Slovenia?
Make the answer very short. -44.2. In the year 2009, what is the difference between the Unemployed and educated female labor force (% of population) of Romania and Unemployed and educated female labor force (% of population) of Slovenia?
Ensure brevity in your answer.  0.9. In the year 2010, what is the difference between the Unemployed and educated female labor force (% of population) of Cyprus and Unemployed and educated female labor force (% of population) of Romania?
Offer a very short reply. -30.3. In the year 2010, what is the difference between the Unemployed and educated female labor force (% of population) of Cyprus and Unemployed and educated female labor force (% of population) of Slovenia?
Offer a terse response. -23. In the year 2010, what is the difference between the Unemployed and educated female labor force (% of population) in Portugal and Unemployed and educated female labor force (% of population) in Romania?
Make the answer very short. -47.2. In the year 2010, what is the difference between the Unemployed and educated female labor force (% of population) of Portugal and Unemployed and educated female labor force (% of population) of Slovenia?
Give a very brief answer. -39.9. In the year 2011, what is the difference between the Unemployed and educated female labor force (% of population) of Cyprus and Unemployed and educated female labor force (% of population) of Portugal?
Ensure brevity in your answer.  17.6. In the year 2011, what is the difference between the Unemployed and educated female labor force (% of population) in Cyprus and Unemployed and educated female labor force (% of population) in Romania?
Your answer should be compact. -25.2. In the year 2011, what is the difference between the Unemployed and educated female labor force (% of population) in Cyprus and Unemployed and educated female labor force (% of population) in Slovenia?
Your response must be concise. -20.6. In the year 2011, what is the difference between the Unemployed and educated female labor force (% of population) in Portugal and Unemployed and educated female labor force (% of population) in Romania?
Ensure brevity in your answer.  -42.8. In the year 2011, what is the difference between the Unemployed and educated female labor force (% of population) in Portugal and Unemployed and educated female labor force (% of population) in Slovenia?
Give a very brief answer. -38.2. In the year 2011, what is the difference between the Unemployed and educated female labor force (% of population) in Romania and Unemployed and educated female labor force (% of population) in Slovenia?
Ensure brevity in your answer.  4.6. In the year 2012, what is the difference between the Unemployed and educated female labor force (% of population) in Cyprus and Unemployed and educated female labor force (% of population) in Portugal?
Provide a succinct answer. 8.1. In the year 2012, what is the difference between the Unemployed and educated female labor force (% of population) in Cyprus and Unemployed and educated female labor force (% of population) in Romania?
Your response must be concise. -29. In the year 2012, what is the difference between the Unemployed and educated female labor force (% of population) in Cyprus and Unemployed and educated female labor force (% of population) in Slovenia?
Your response must be concise. -19.5. In the year 2012, what is the difference between the Unemployed and educated female labor force (% of population) in Portugal and Unemployed and educated female labor force (% of population) in Romania?
Your response must be concise. -37.1. In the year 2012, what is the difference between the Unemployed and educated female labor force (% of population) of Portugal and Unemployed and educated female labor force (% of population) of Slovenia?
Make the answer very short. -27.6. In the year 2012, what is the difference between the Unemployed and educated female labor force (% of population) of Romania and Unemployed and educated female labor force (% of population) of Slovenia?
Give a very brief answer. 9.5. In the year 2013, what is the difference between the Unemployed and educated female labor force (% of population) in Cyprus and Unemployed and educated female labor force (% of population) in Portugal?
Give a very brief answer. 12.1. In the year 2013, what is the difference between the Unemployed and educated female labor force (% of population) of Cyprus and Unemployed and educated female labor force (% of population) of Romania?
Keep it short and to the point. -23.4. In the year 2013, what is the difference between the Unemployed and educated female labor force (% of population) of Cyprus and Unemployed and educated female labor force (% of population) of Slovenia?
Keep it short and to the point. -17. In the year 2013, what is the difference between the Unemployed and educated female labor force (% of population) in Portugal and Unemployed and educated female labor force (% of population) in Romania?
Provide a short and direct response. -35.5. In the year 2013, what is the difference between the Unemployed and educated female labor force (% of population) of Portugal and Unemployed and educated female labor force (% of population) of Slovenia?
Ensure brevity in your answer.  -29.1. What is the ratio of the Unemployed and educated female labor force (% of population) of Cyprus in 2006 to that in 2007?
Provide a succinct answer. 1.01. What is the ratio of the Unemployed and educated female labor force (% of population) in Portugal in 2006 to that in 2007?
Offer a terse response. 1.07. What is the ratio of the Unemployed and educated female labor force (% of population) in Romania in 2006 to that in 2007?
Provide a succinct answer. 1.01. What is the ratio of the Unemployed and educated female labor force (% of population) of Slovenia in 2006 to that in 2007?
Ensure brevity in your answer.  1.08. What is the ratio of the Unemployed and educated female labor force (% of population) of Cyprus in 2006 to that in 2008?
Offer a very short reply. 0.96. What is the ratio of the Unemployed and educated female labor force (% of population) in Portugal in 2006 to that in 2008?
Make the answer very short. 1. What is the ratio of the Unemployed and educated female labor force (% of population) in Romania in 2006 to that in 2008?
Provide a short and direct response. 1.02. What is the ratio of the Unemployed and educated female labor force (% of population) of Slovenia in 2006 to that in 2008?
Provide a succinct answer. 1.18. What is the ratio of the Unemployed and educated female labor force (% of population) in Cyprus in 2006 to that in 2009?
Your answer should be compact. 0.95. What is the ratio of the Unemployed and educated female labor force (% of population) of Romania in 2006 to that in 2009?
Your answer should be compact. 1.05. What is the ratio of the Unemployed and educated female labor force (% of population) in Slovenia in 2006 to that in 2009?
Keep it short and to the point. 1.09. What is the ratio of the Unemployed and educated female labor force (% of population) of Cyprus in 2006 to that in 2010?
Keep it short and to the point. 0.95. What is the ratio of the Unemployed and educated female labor force (% of population) in Portugal in 2006 to that in 2010?
Your answer should be very brief. 0.79. What is the ratio of the Unemployed and educated female labor force (% of population) in Romania in 2006 to that in 2010?
Provide a succinct answer. 0.99. What is the ratio of the Unemployed and educated female labor force (% of population) of Slovenia in 2006 to that in 2010?
Give a very brief answer. 1.13. What is the ratio of the Unemployed and educated female labor force (% of population) in Cyprus in 2006 to that in 2011?
Make the answer very short. 0.88. What is the ratio of the Unemployed and educated female labor force (% of population) in Portugal in 2006 to that in 2011?
Provide a succinct answer. 0.71. What is the ratio of the Unemployed and educated female labor force (% of population) of Slovenia in 2006 to that in 2011?
Give a very brief answer. 1.12. What is the ratio of the Unemployed and educated female labor force (% of population) of Cyprus in 2006 to that in 2012?
Make the answer very short. 1. What is the ratio of the Unemployed and educated female labor force (% of population) of Portugal in 2006 to that in 2012?
Give a very brief answer. 0.59. What is the ratio of the Unemployed and educated female labor force (% of population) of Romania in 2006 to that in 2012?
Give a very brief answer. 1.04. What is the ratio of the Unemployed and educated female labor force (% of population) in Slovenia in 2006 to that in 2012?
Provide a succinct answer. 1.24. What is the ratio of the Unemployed and educated female labor force (% of population) in Cyprus in 2006 to that in 2013?
Your response must be concise. 0.89. What is the ratio of the Unemployed and educated female labor force (% of population) in Portugal in 2006 to that in 2013?
Offer a terse response. 0.58. What is the ratio of the Unemployed and educated female labor force (% of population) of Romania in 2006 to that in 2013?
Your answer should be very brief. 1.06. What is the ratio of the Unemployed and educated female labor force (% of population) in Slovenia in 2006 to that in 2013?
Your answer should be very brief. 1.2. What is the ratio of the Unemployed and educated female labor force (% of population) of Cyprus in 2007 to that in 2008?
Ensure brevity in your answer.  0.94. What is the ratio of the Unemployed and educated female labor force (% of population) in Portugal in 2007 to that in 2008?
Provide a succinct answer. 0.93. What is the ratio of the Unemployed and educated female labor force (% of population) in Romania in 2007 to that in 2008?
Offer a very short reply. 1.01. What is the ratio of the Unemployed and educated female labor force (% of population) of Slovenia in 2007 to that in 2008?
Offer a very short reply. 1.1. What is the ratio of the Unemployed and educated female labor force (% of population) in Portugal in 2007 to that in 2009?
Ensure brevity in your answer.  0.8. What is the ratio of the Unemployed and educated female labor force (% of population) in Romania in 2007 to that in 2009?
Provide a short and direct response. 1.04. What is the ratio of the Unemployed and educated female labor force (% of population) of Cyprus in 2007 to that in 2010?
Your answer should be very brief. 0.94. What is the ratio of the Unemployed and educated female labor force (% of population) of Portugal in 2007 to that in 2010?
Make the answer very short. 0.73. What is the ratio of the Unemployed and educated female labor force (% of population) of Slovenia in 2007 to that in 2010?
Make the answer very short. 1.05. What is the ratio of the Unemployed and educated female labor force (% of population) of Cyprus in 2007 to that in 2011?
Provide a short and direct response. 0.87. What is the ratio of the Unemployed and educated female labor force (% of population) in Portugal in 2007 to that in 2011?
Keep it short and to the point. 0.66. What is the ratio of the Unemployed and educated female labor force (% of population) in Romania in 2007 to that in 2011?
Offer a very short reply. 1.01. What is the ratio of the Unemployed and educated female labor force (% of population) in Slovenia in 2007 to that in 2011?
Provide a succinct answer. 1.04. What is the ratio of the Unemployed and educated female labor force (% of population) in Portugal in 2007 to that in 2012?
Keep it short and to the point. 0.55. What is the ratio of the Unemployed and educated female labor force (% of population) of Romania in 2007 to that in 2012?
Provide a short and direct response. 1.03. What is the ratio of the Unemployed and educated female labor force (% of population) of Slovenia in 2007 to that in 2012?
Offer a very short reply. 1.15. What is the ratio of the Unemployed and educated female labor force (% of population) in Cyprus in 2007 to that in 2013?
Your answer should be compact. 0.88. What is the ratio of the Unemployed and educated female labor force (% of population) of Portugal in 2007 to that in 2013?
Provide a short and direct response. 0.55. What is the ratio of the Unemployed and educated female labor force (% of population) in Romania in 2007 to that in 2013?
Your response must be concise. 1.05. What is the ratio of the Unemployed and educated female labor force (% of population) in Slovenia in 2007 to that in 2013?
Make the answer very short. 1.11. What is the ratio of the Unemployed and educated female labor force (% of population) in Portugal in 2008 to that in 2009?
Offer a very short reply. 0.86. What is the ratio of the Unemployed and educated female labor force (% of population) of Romania in 2008 to that in 2009?
Offer a terse response. 1.03. What is the ratio of the Unemployed and educated female labor force (% of population) of Slovenia in 2008 to that in 2009?
Your answer should be compact. 0.92. What is the ratio of the Unemployed and educated female labor force (% of population) of Portugal in 2008 to that in 2010?
Your answer should be very brief. 0.79. What is the ratio of the Unemployed and educated female labor force (% of population) of Romania in 2008 to that in 2010?
Make the answer very short. 0.98. What is the ratio of the Unemployed and educated female labor force (% of population) in Slovenia in 2008 to that in 2010?
Keep it short and to the point. 0.96. What is the ratio of the Unemployed and educated female labor force (% of population) of Cyprus in 2008 to that in 2011?
Keep it short and to the point. 0.92. What is the ratio of the Unemployed and educated female labor force (% of population) in Portugal in 2008 to that in 2011?
Provide a short and direct response. 0.71. What is the ratio of the Unemployed and educated female labor force (% of population) in Romania in 2008 to that in 2011?
Keep it short and to the point. 1. What is the ratio of the Unemployed and educated female labor force (% of population) in Slovenia in 2008 to that in 2011?
Provide a short and direct response. 0.95. What is the ratio of the Unemployed and educated female labor force (% of population) of Cyprus in 2008 to that in 2012?
Ensure brevity in your answer.  1.05. What is the ratio of the Unemployed and educated female labor force (% of population) of Portugal in 2008 to that in 2012?
Your answer should be compact. 0.59. What is the ratio of the Unemployed and educated female labor force (% of population) in Romania in 2008 to that in 2012?
Your response must be concise. 1.02. What is the ratio of the Unemployed and educated female labor force (% of population) of Slovenia in 2008 to that in 2012?
Ensure brevity in your answer.  1.05. What is the ratio of the Unemployed and educated female labor force (% of population) in Cyprus in 2008 to that in 2013?
Provide a succinct answer. 0.93. What is the ratio of the Unemployed and educated female labor force (% of population) of Portugal in 2008 to that in 2013?
Your answer should be compact. 0.58. What is the ratio of the Unemployed and educated female labor force (% of population) of Romania in 2008 to that in 2013?
Your response must be concise. 1.04. What is the ratio of the Unemployed and educated female labor force (% of population) in Slovenia in 2008 to that in 2013?
Keep it short and to the point. 1.01. What is the ratio of the Unemployed and educated female labor force (% of population) of Cyprus in 2009 to that in 2010?
Ensure brevity in your answer.  1. What is the ratio of the Unemployed and educated female labor force (% of population) of Portugal in 2009 to that in 2010?
Your response must be concise. 0.92. What is the ratio of the Unemployed and educated female labor force (% of population) of Romania in 2009 to that in 2010?
Keep it short and to the point. 0.94. What is the ratio of the Unemployed and educated female labor force (% of population) in Slovenia in 2009 to that in 2010?
Give a very brief answer. 1.04. What is the ratio of the Unemployed and educated female labor force (% of population) of Cyprus in 2009 to that in 2011?
Offer a very short reply. 0.93. What is the ratio of the Unemployed and educated female labor force (% of population) of Portugal in 2009 to that in 2011?
Your response must be concise. 0.82. What is the ratio of the Unemployed and educated female labor force (% of population) in Romania in 2009 to that in 2011?
Ensure brevity in your answer.  0.97. What is the ratio of the Unemployed and educated female labor force (% of population) of Cyprus in 2009 to that in 2012?
Offer a terse response. 1.05. What is the ratio of the Unemployed and educated female labor force (% of population) in Portugal in 2009 to that in 2012?
Your response must be concise. 0.69. What is the ratio of the Unemployed and educated female labor force (% of population) in Romania in 2009 to that in 2012?
Offer a terse response. 0.99. What is the ratio of the Unemployed and educated female labor force (% of population) in Slovenia in 2009 to that in 2012?
Your answer should be compact. 1.14. What is the ratio of the Unemployed and educated female labor force (% of population) in Cyprus in 2009 to that in 2013?
Your answer should be very brief. 0.94. What is the ratio of the Unemployed and educated female labor force (% of population) of Portugal in 2009 to that in 2013?
Give a very brief answer. 0.68. What is the ratio of the Unemployed and educated female labor force (% of population) of Romania in 2009 to that in 2013?
Ensure brevity in your answer.  1.01. What is the ratio of the Unemployed and educated female labor force (% of population) in Slovenia in 2009 to that in 2013?
Offer a very short reply. 1.1. What is the ratio of the Unemployed and educated female labor force (% of population) in Cyprus in 2010 to that in 2011?
Your response must be concise. 0.93. What is the ratio of the Unemployed and educated female labor force (% of population) in Portugal in 2010 to that in 2011?
Your answer should be very brief. 0.9. What is the ratio of the Unemployed and educated female labor force (% of population) of Slovenia in 2010 to that in 2011?
Offer a very short reply. 0.99. What is the ratio of the Unemployed and educated female labor force (% of population) in Cyprus in 2010 to that in 2012?
Give a very brief answer. 1.05. What is the ratio of the Unemployed and educated female labor force (% of population) in Portugal in 2010 to that in 2012?
Ensure brevity in your answer.  0.76. What is the ratio of the Unemployed and educated female labor force (% of population) in Romania in 2010 to that in 2012?
Your answer should be very brief. 1.05. What is the ratio of the Unemployed and educated female labor force (% of population) of Slovenia in 2010 to that in 2012?
Ensure brevity in your answer.  1.1. What is the ratio of the Unemployed and educated female labor force (% of population) in Cyprus in 2010 to that in 2013?
Ensure brevity in your answer.  0.94. What is the ratio of the Unemployed and educated female labor force (% of population) in Portugal in 2010 to that in 2013?
Give a very brief answer. 0.74. What is the ratio of the Unemployed and educated female labor force (% of population) in Romania in 2010 to that in 2013?
Make the answer very short. 1.07. What is the ratio of the Unemployed and educated female labor force (% of population) in Slovenia in 2010 to that in 2013?
Ensure brevity in your answer.  1.06. What is the ratio of the Unemployed and educated female labor force (% of population) in Cyprus in 2011 to that in 2012?
Provide a succinct answer. 1.14. What is the ratio of the Unemployed and educated female labor force (% of population) of Portugal in 2011 to that in 2012?
Provide a short and direct response. 0.84. What is the ratio of the Unemployed and educated female labor force (% of population) of Romania in 2011 to that in 2012?
Keep it short and to the point. 1.02. What is the ratio of the Unemployed and educated female labor force (% of population) of Slovenia in 2011 to that in 2012?
Your answer should be very brief. 1.11. What is the ratio of the Unemployed and educated female labor force (% of population) of Cyprus in 2011 to that in 2013?
Your answer should be compact. 1.01. What is the ratio of the Unemployed and educated female labor force (% of population) in Portugal in 2011 to that in 2013?
Your answer should be compact. 0.83. What is the ratio of the Unemployed and educated female labor force (% of population) in Romania in 2011 to that in 2013?
Provide a succinct answer. 1.04. What is the ratio of the Unemployed and educated female labor force (% of population) of Slovenia in 2011 to that in 2013?
Your response must be concise. 1.07. What is the ratio of the Unemployed and educated female labor force (% of population) in Cyprus in 2012 to that in 2013?
Make the answer very short. 0.89. What is the ratio of the Unemployed and educated female labor force (% of population) in Portugal in 2012 to that in 2013?
Your answer should be very brief. 0.98. What is the ratio of the Unemployed and educated female labor force (% of population) in Romania in 2012 to that in 2013?
Provide a short and direct response. 1.02. What is the ratio of the Unemployed and educated female labor force (% of population) of Slovenia in 2012 to that in 2013?
Ensure brevity in your answer.  0.97. What is the difference between the highest and the second highest Unemployed and educated female labor force (% of population) of Cyprus?
Provide a succinct answer. 0.5. What is the difference between the highest and the second highest Unemployed and educated female labor force (% of population) in Portugal?
Offer a terse response. 0.5. What is the difference between the highest and the second highest Unemployed and educated female labor force (% of population) in Romania?
Make the answer very short. 0.4. What is the difference between the highest and the lowest Unemployed and educated female labor force (% of population) in Portugal?
Make the answer very short. 13.1. What is the difference between the highest and the lowest Unemployed and educated female labor force (% of population) of Slovenia?
Provide a short and direct response. 13.5. 